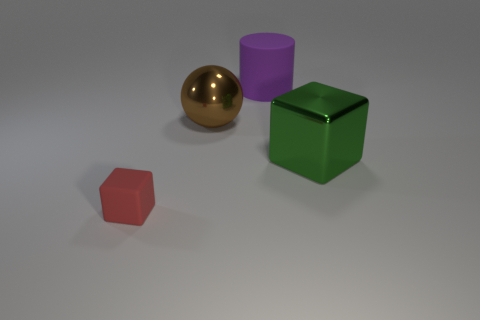Are there any other things that have the same size as the rubber cube?
Your response must be concise. No. Is the shape of the large green metallic thing the same as the rubber object behind the red thing?
Keep it short and to the point. No. There is a tiny red rubber block; how many big blocks are on the left side of it?
Offer a terse response. 0. Are there any cylinders of the same size as the green cube?
Your answer should be compact. Yes. There is a matte thing that is behind the small red matte cube; does it have the same shape as the small red matte object?
Your response must be concise. No. The matte cylinder is what color?
Your response must be concise. Purple. Is there a small red rubber sphere?
Provide a short and direct response. No. The red object that is made of the same material as the cylinder is what size?
Your response must be concise. Small. There is a rubber thing on the right side of the matte object to the left of the matte thing that is right of the small red matte thing; what shape is it?
Keep it short and to the point. Cylinder. Are there the same number of red blocks in front of the small red cube and tiny red matte cubes?
Give a very brief answer. No. 